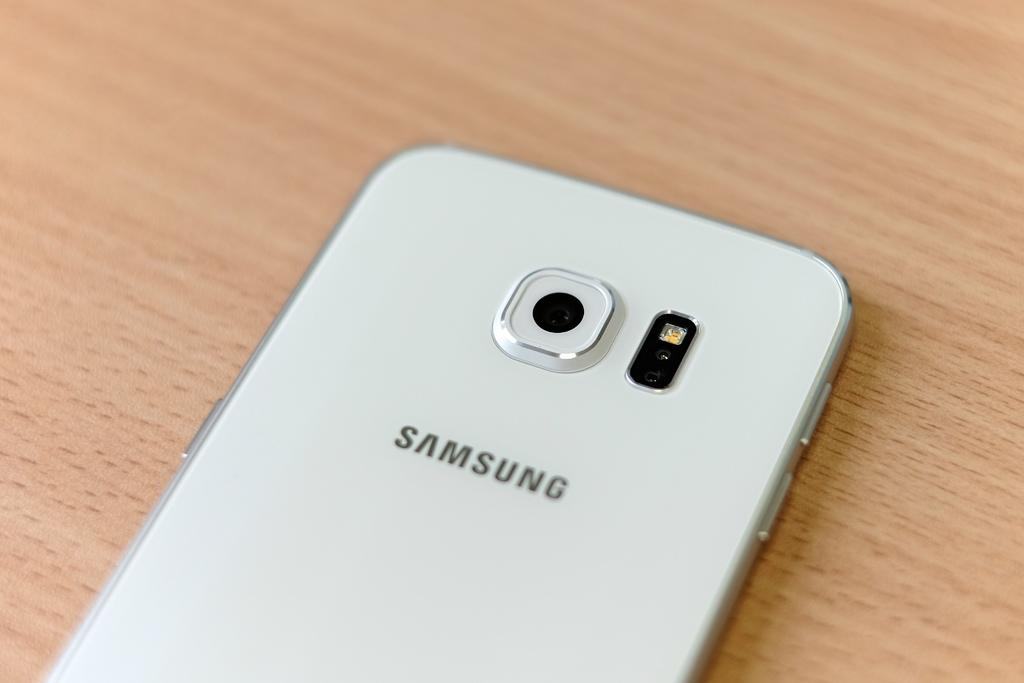<image>
Write a terse but informative summary of the picture. A white Samsung phone on an oak table. 